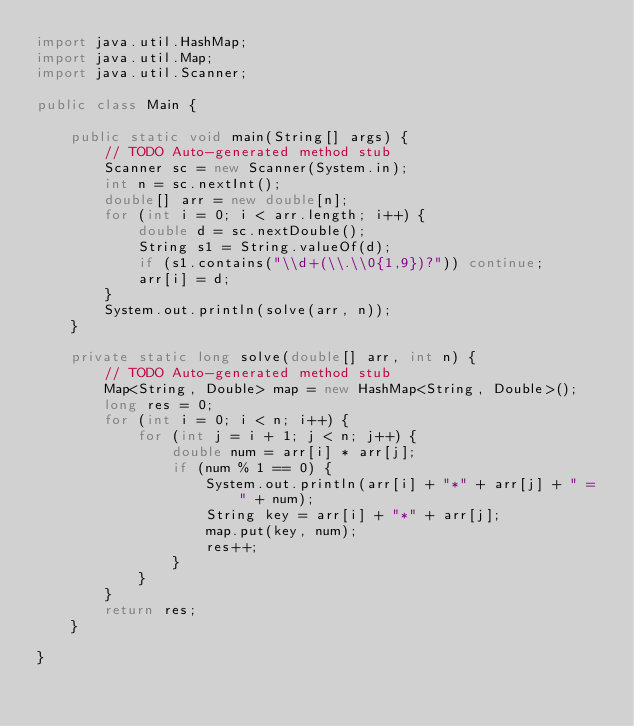<code> <loc_0><loc_0><loc_500><loc_500><_Java_>import java.util.HashMap;
import java.util.Map;
import java.util.Scanner;

public class Main {

	public static void main(String[] args) {
		// TODO Auto-generated method stub
		Scanner sc = new Scanner(System.in);
		int n = sc.nextInt();
		double[] arr = new double[n];
		for (int i = 0; i < arr.length; i++) {
			double d = sc.nextDouble();
			String s1 = String.valueOf(d);
			if (s1.contains("\\d+(\\.\\0{1,9})?")) continue;
			arr[i] = d;
		}
		System.out.println(solve(arr, n));
	}

	private static long solve(double[] arr, int n) {
		// TODO Auto-generated method stub
		Map<String, Double> map = new HashMap<String, Double>();
		long res = 0;
		for (int i = 0; i < n; i++) {
			for (int j = i + 1; j < n; j++) {
				double num = arr[i] * arr[j];
				if (num % 1 == 0) {
					System.out.println(arr[i] + "*" + arr[j] + " = " + num);
					String key = arr[i] + "*" + arr[j];
					map.put(key, num);
					res++;
				}	
			}
		}
		return res;
	}

}
</code> 